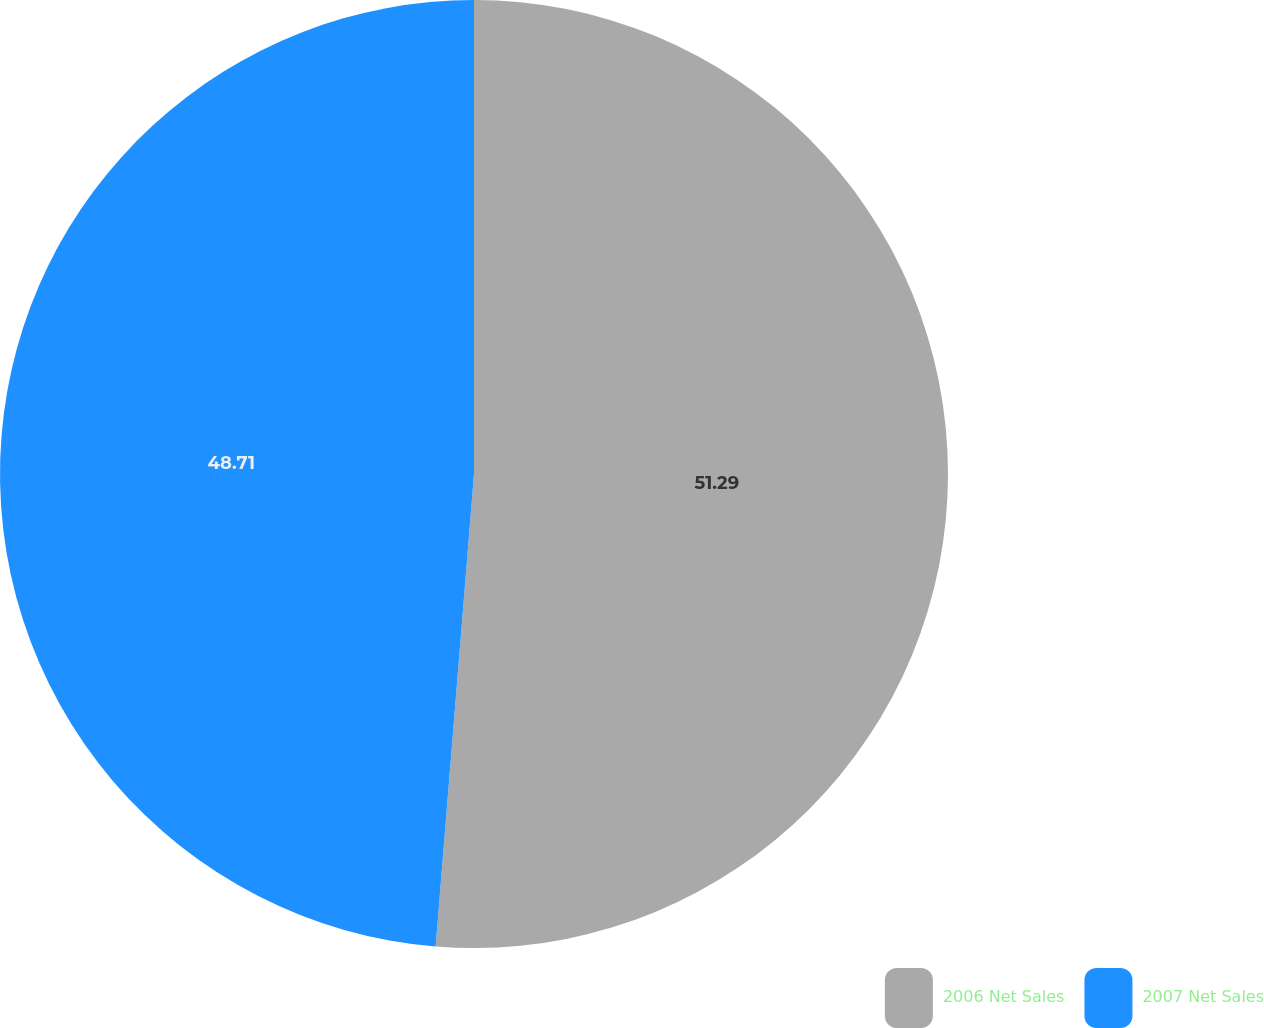Convert chart to OTSL. <chart><loc_0><loc_0><loc_500><loc_500><pie_chart><fcel>2006 Net Sales<fcel>2007 Net Sales<nl><fcel>51.29%<fcel>48.71%<nl></chart> 